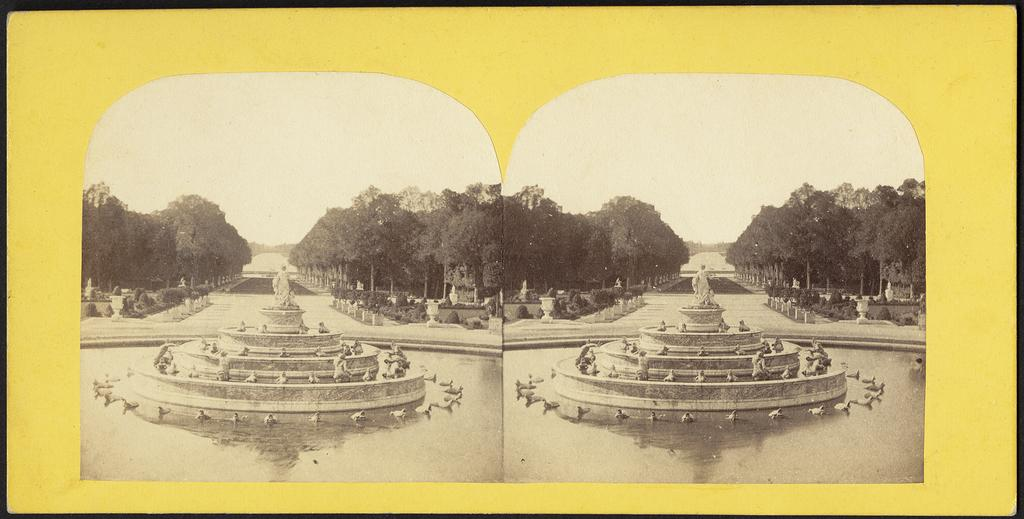What type of vegetation is present on both sides of the image? There are trees on both sides of the image. What objects are in front in the image? There are two fortunes and statues in front. What is the nature of the landscape in the image? There is water in front. What is the color scheme of the image? The image is in black and white. What is the color of the border in the image? The border is in yellow and black color. Can you see a curtain in the image? No, there is no curtain present in the image. 